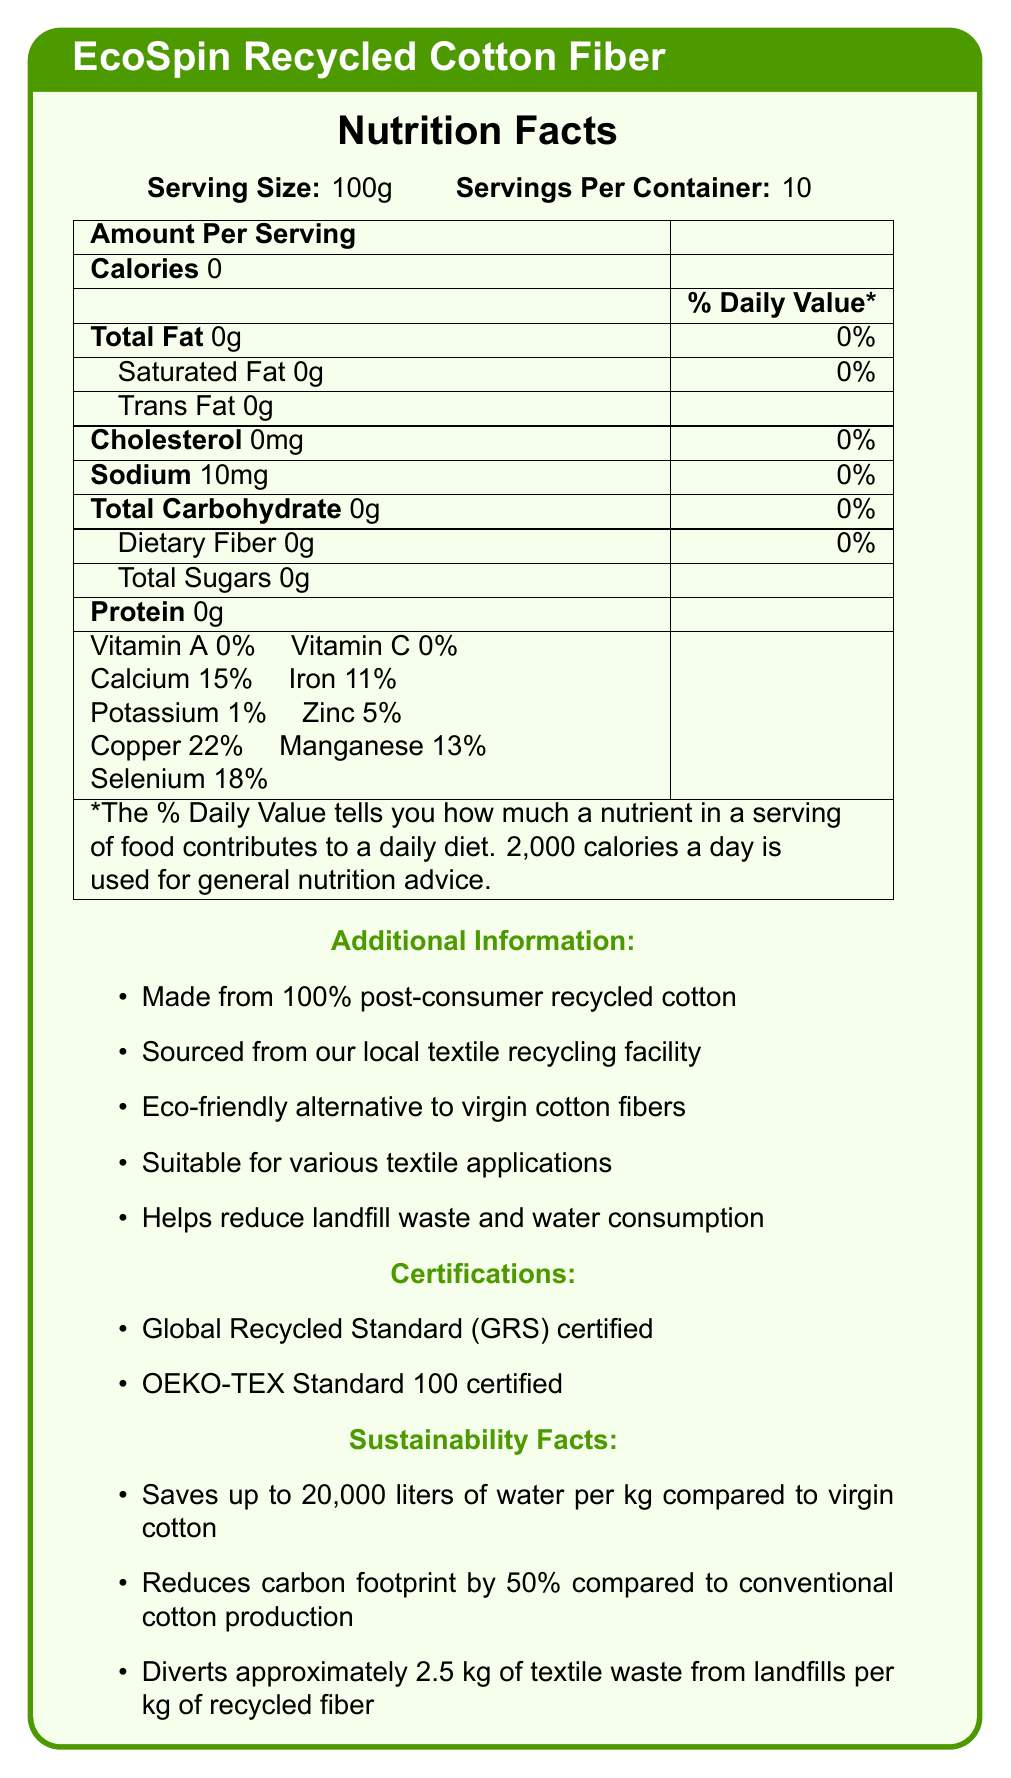What is the serving size of EcoSpin Recycled Cotton Fiber? The document explicitly states that the serving size is 100g.
Answer: 100g How much sodium is in one serving of EcoSpin Recycled Cotton Fiber? The document lists the amount of sodium as 10mg per serving.
Answer: 10mg What percentage of the Daily Value for calcium is provided by one serving? The document indicates that one serving contains 15% of the Daily Value for calcium.
Answer: 15% From which material is EcoSpin Recycled Cotton Fiber made? The additional information section states that the product is made from 100% post-consumer recycled cotton.
Answer: 100% post-consumer recycled cotton How much textile waste is diverted from landfills per kilogram of recycled fiber? The sustainability facts mention that about 2.5 kg of textile waste is diverted per kilogram of recycled fiber.
Answer: Approximately 2.5 kg What certifications does EcoSpin Recycled Cotton Fiber hold? A. Global Recycled Standard (GRS) B. OEKO-TEX Standard 100 C. GOTS Organic D. Both A and B The document lists both the Global Recycled Standard (GRS) and OEKO-TEX Standard 100 as certifications.
Answer: D. Both A and B How much iron does one serving of EcoSpin Recycled Cotton Fiber contain? A. 1% B. 11% C. 5% D. 22% The document mentions that one serving contains 11% of the Daily Value for iron.
Answer: B. 11% Is there any protein in one serving of EcoSpin Recycled Cotton Fiber? The document shows that there is 0g of protein in one serving.
Answer: No What is the main purpose of the EcoSpin Recycled Cotton Fiber product? The main idea of the document is that EcoSpin Recycled Cotton Fiber is an eco-friendly alternative made from recycled cotton, suitable for various textile applications.
Answer: Eco-friendly textile alternative What is the length of EcoSpin Recycled Cotton Fiber? The document does not provide information about the length in the visual information provided.
Answer: Cannot be determined How much water is saved per kilogram of EcoSpin Recycled Cotton Fiber compared to virgin cotton? The sustainability facts state that up to 20,000 liters of water are saved per kilogram compared to virgin cotton.
Answer: Up to 20,000 liters What is the strength of EcoSpin Recycled Cotton Fiber? The fiber properties section describes the strength as "Medium."
Answer: Medium How much selenium does one serving contain? One serving contains 0.1 mg of selenium according to the document.
Answer: 0.1 mg What are the major benefits of using EcoSpin Recycled Cotton Fiber? The document lists these benefits in the additional information section.
Answer: Reduces landfill waste and water consumption, eco-friendly alternative to virgin cotton, suitable for various textile applications What are some suggested uses for EcoSpin Recycled Cotton Fiber? The recommended uses section of the document offers these suggestions.
Answer: Blending with virgin fibers, creating eco-friendly clothing, manufacturing sustainable home textiles, producing industrial textiles 